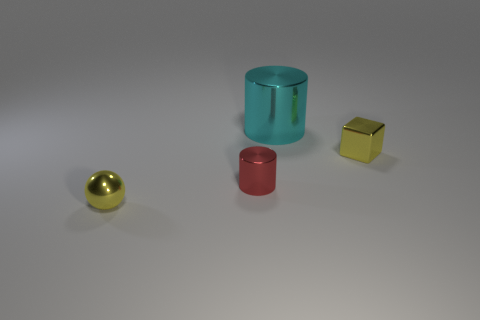Add 1 small gray matte spheres. How many objects exist? 5 Subtract all blocks. How many objects are left? 3 Subtract 1 yellow balls. How many objects are left? 3 Subtract all big green metal spheres. Subtract all shiny blocks. How many objects are left? 3 Add 1 big cylinders. How many big cylinders are left? 2 Add 3 large metal cylinders. How many large metal cylinders exist? 4 